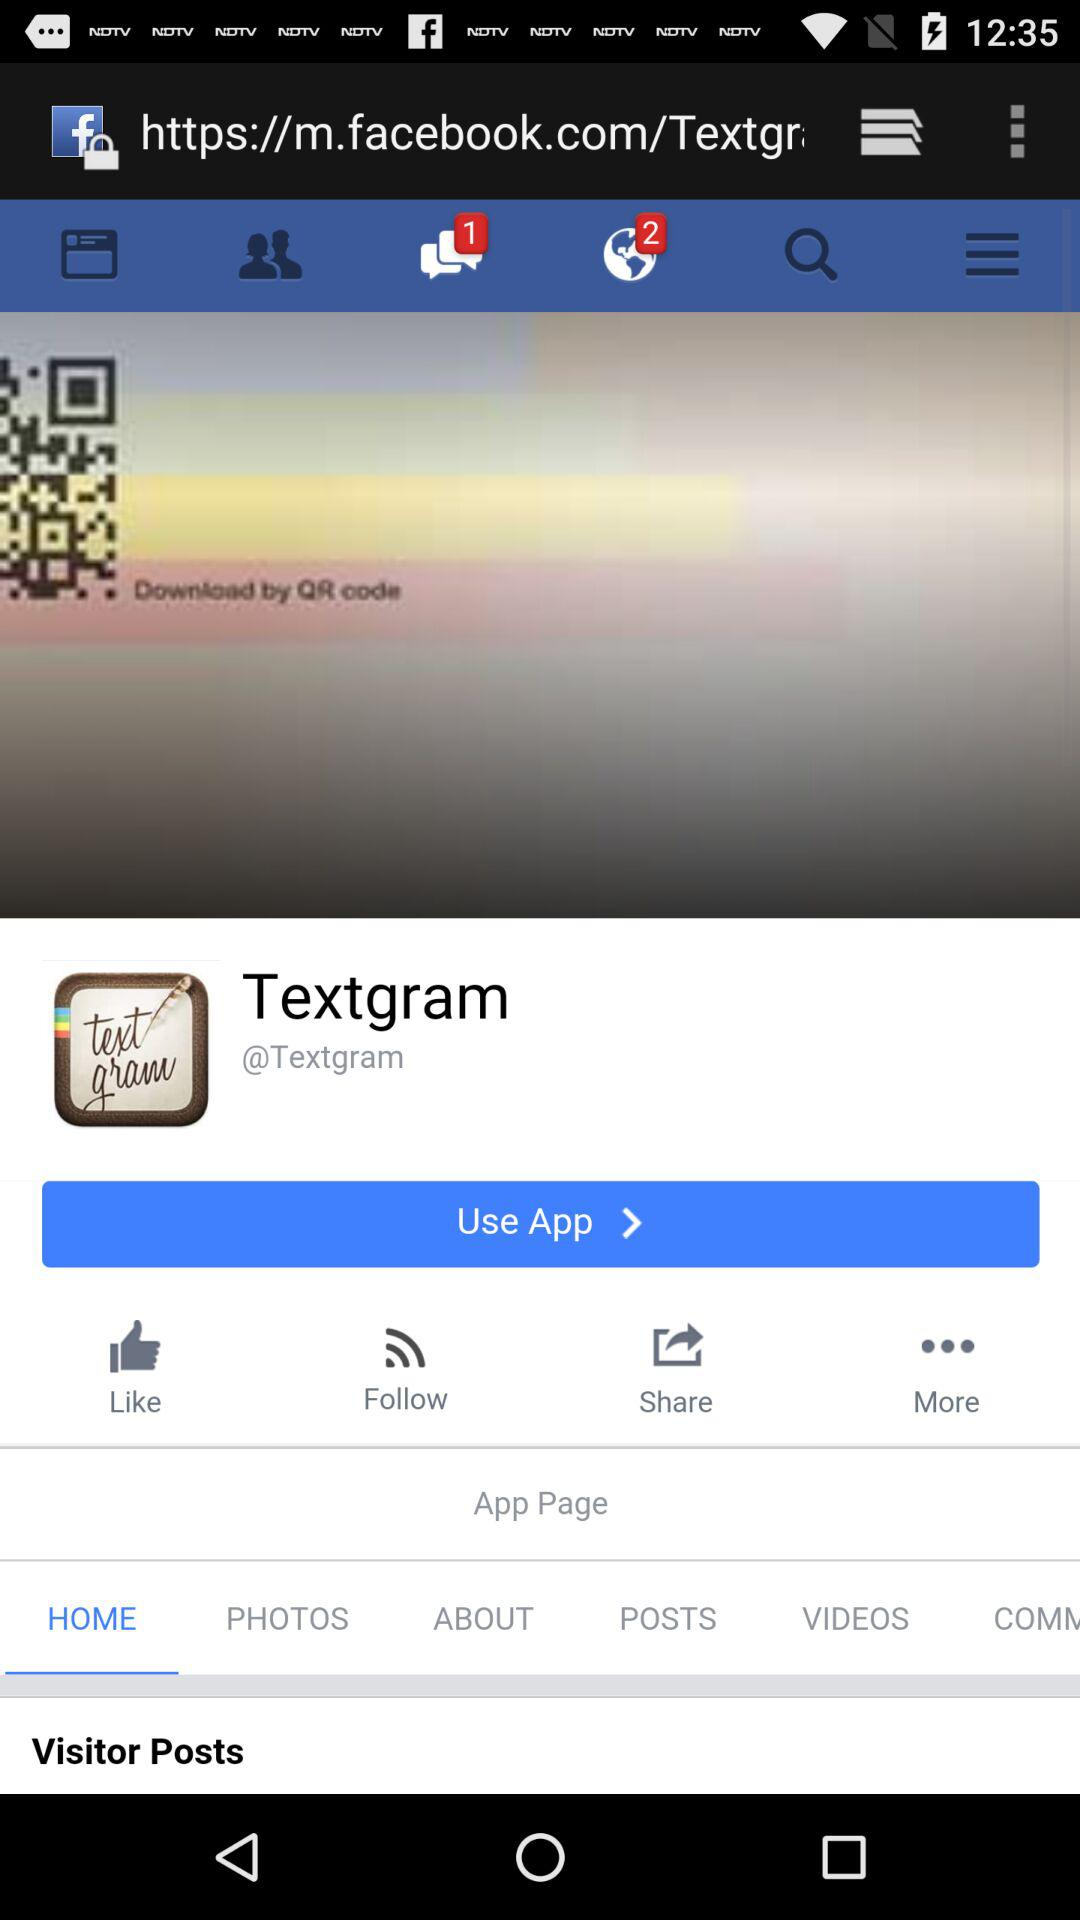Which is the selected tab? The selected tab is "HOME". 